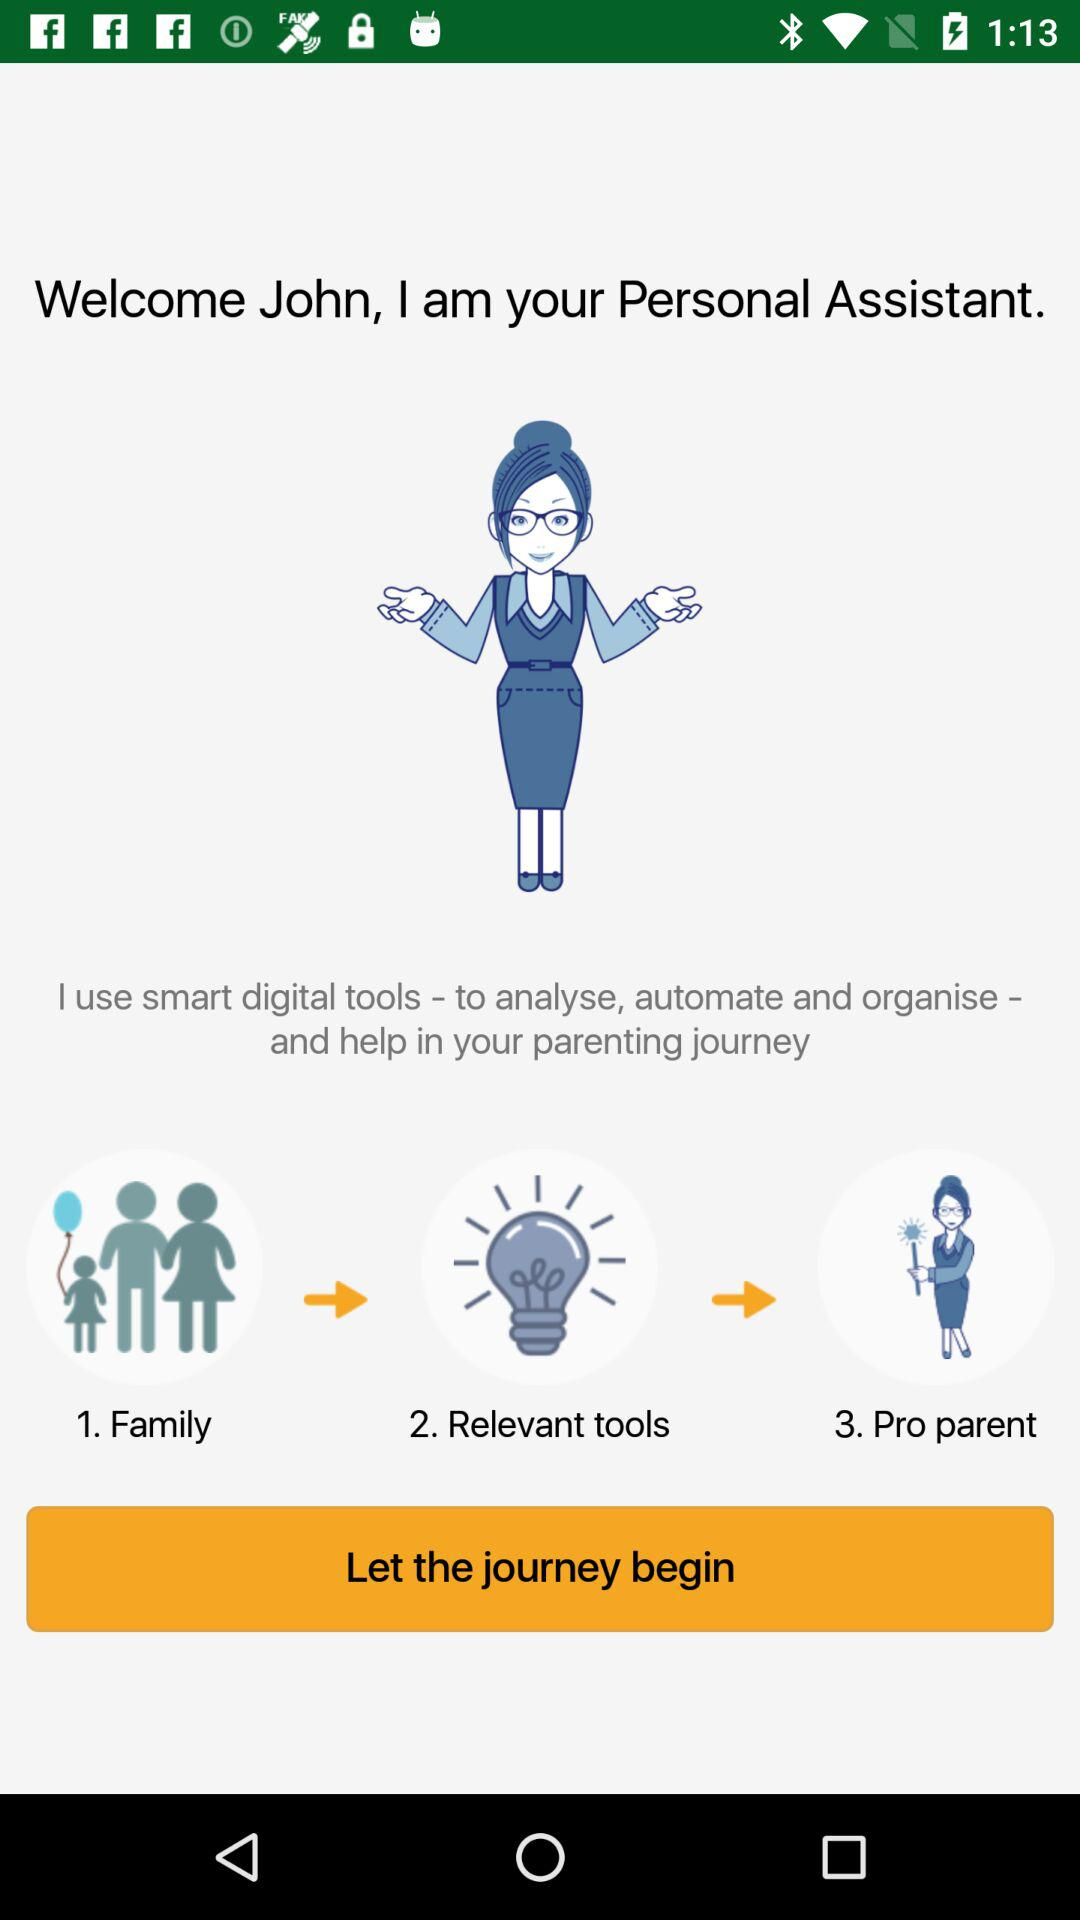What is the total number of steps?
When the provided information is insufficient, respond with <no answer>. <no answer> 